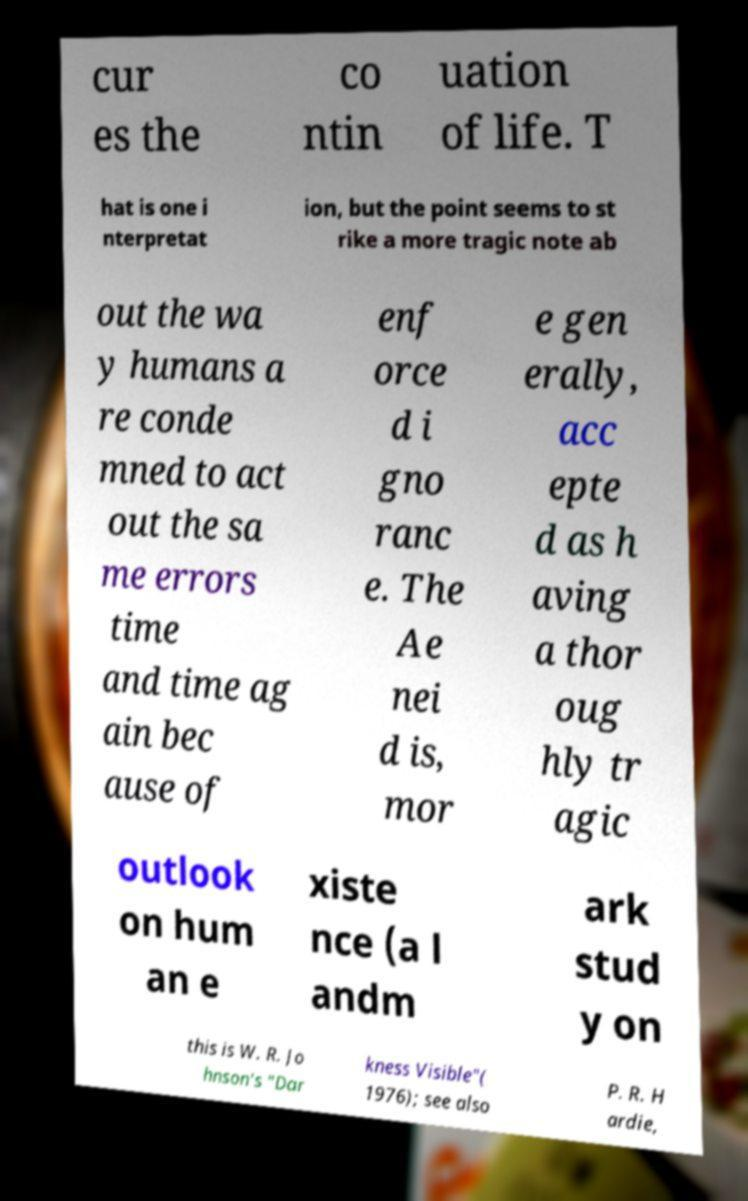What messages or text are displayed in this image? I need them in a readable, typed format. cur es the co ntin uation of life. T hat is one i nterpretat ion, but the point seems to st rike a more tragic note ab out the wa y humans a re conde mned to act out the sa me errors time and time ag ain bec ause of enf orce d i gno ranc e. The Ae nei d is, mor e gen erally, acc epte d as h aving a thor oug hly tr agic outlook on hum an e xiste nce (a l andm ark stud y on this is W. R. Jo hnson's "Dar kness Visible"( 1976); see also P. R. H ardie, 